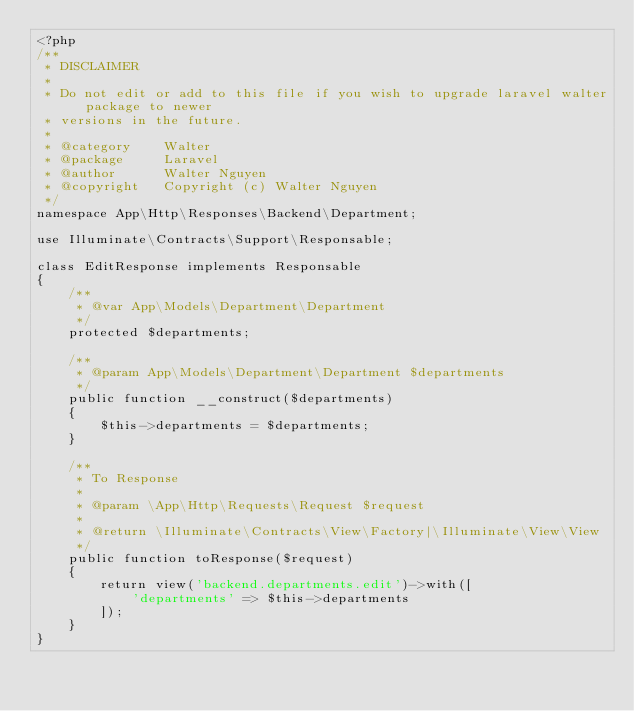Convert code to text. <code><loc_0><loc_0><loc_500><loc_500><_PHP_><?php
/**
 * DISCLAIMER
 *
 * Do not edit or add to this file if you wish to upgrade laravel walter package to newer
 * versions in the future.
 *
 * @category    Walter
 * @package     Laravel
 * @author      Walter Nguyen
 * @copyright   Copyright (c) Walter Nguyen
 */
namespace App\Http\Responses\Backend\Department;

use Illuminate\Contracts\Support\Responsable;

class EditResponse implements Responsable
{
    /**
     * @var App\Models\Department\Department
     */
    protected $departments;

    /**
     * @param App\Models\Department\Department $departments
     */
    public function __construct($departments)
    {
        $this->departments = $departments;
    }

    /**
     * To Response
     *
     * @param \App\Http\Requests\Request $request
     *
     * @return \Illuminate\Contracts\View\Factory|\Illuminate\View\View
     */
    public function toResponse($request)
    {
        return view('backend.departments.edit')->with([
            'departments' => $this->departments
        ]);
    }
}</code> 